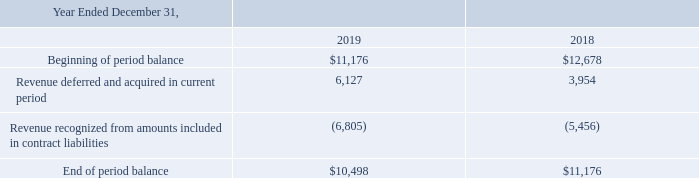Contract Liabilities
Contract liabilities include payments received in advance of performance under the contract, and are realized with the associated revenue recognized under the contract. The changes in our contract liabilities are as follows (in thousands):
The revenue recognized from amounts included in contract liabilities primarily relates to prepayment contracts with customers as well as payments of activation fees.
What did contract liabilities include? Payments received in advance of performance under the contract, and are realized with the associated revenue recognized under the contract. What did the revenue recognized from amounts included in contract liabilities primarily related to? Prepayment contracts with customers as well as payments of activation fees. Which years does the table provide information for the changes in the company's contract liabilities? 2019, 2018. What was the change in Revenue deferred and acquired in current period between 2018 and 2019?
Answer scale should be: thousand. 6,127-3,954
Answer: 2173. How many years did the Beginning of period balance exceed $11,000 thousand? 2019##2018
Answer: 2. What was the percentage change in the End of period balance between 2018 and 2019?
Answer scale should be: percent. (10,498-11,176)/11,176
Answer: -6.07. 